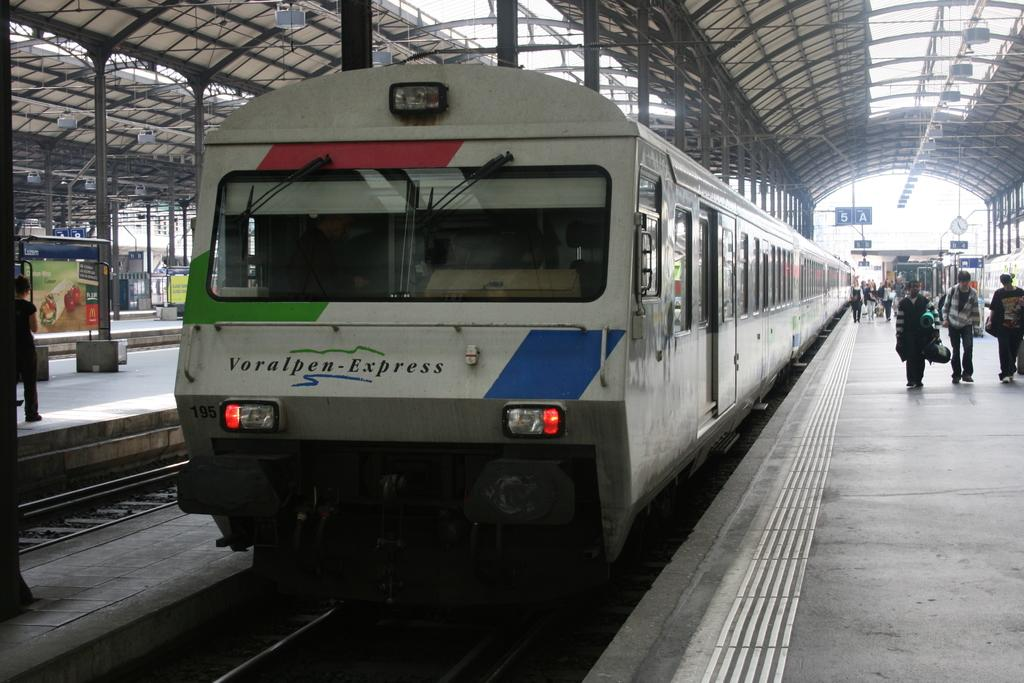<image>
Provide a brief description of the given image. A Voralpen Express train is in the station. 